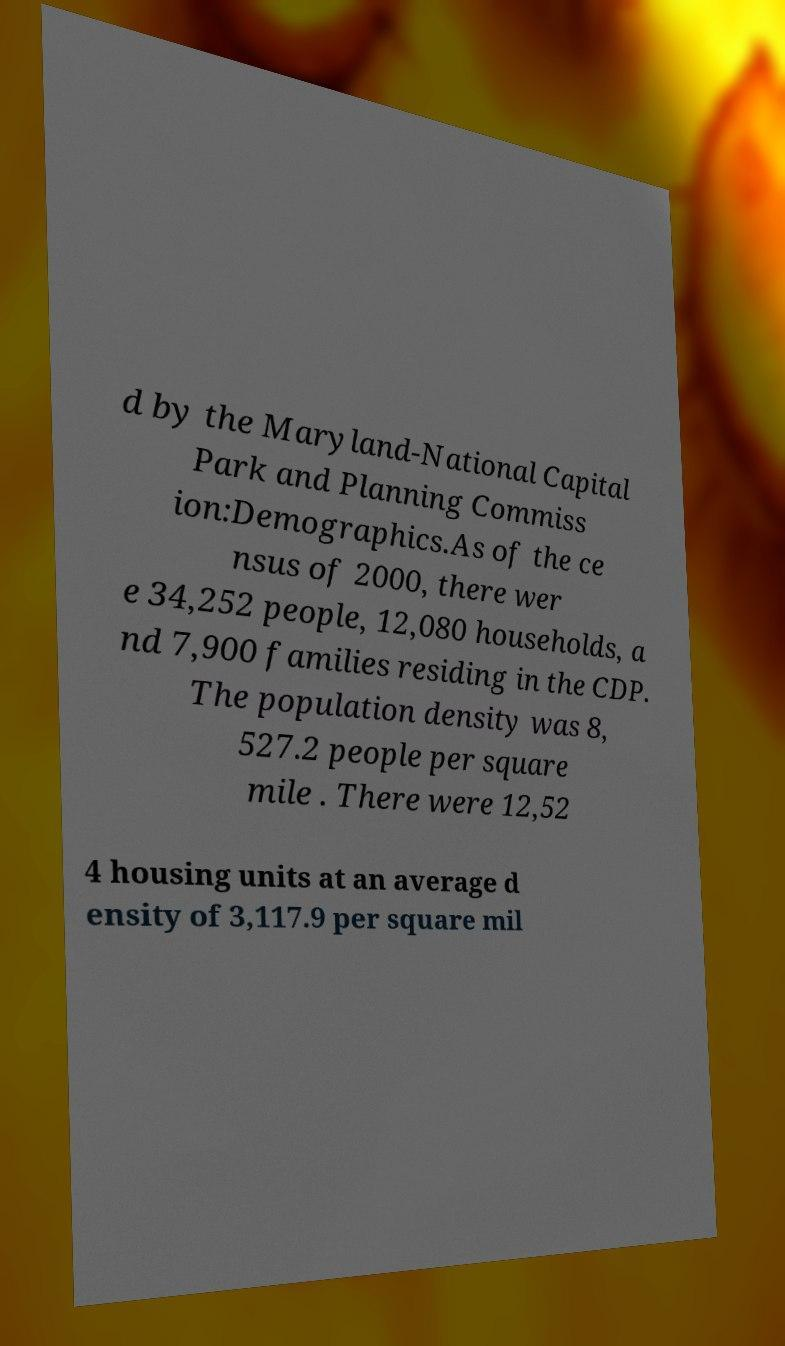There's text embedded in this image that I need extracted. Can you transcribe it verbatim? d by the Maryland-National Capital Park and Planning Commiss ion:Demographics.As of the ce nsus of 2000, there wer e 34,252 people, 12,080 households, a nd 7,900 families residing in the CDP. The population density was 8, 527.2 people per square mile . There were 12,52 4 housing units at an average d ensity of 3,117.9 per square mil 